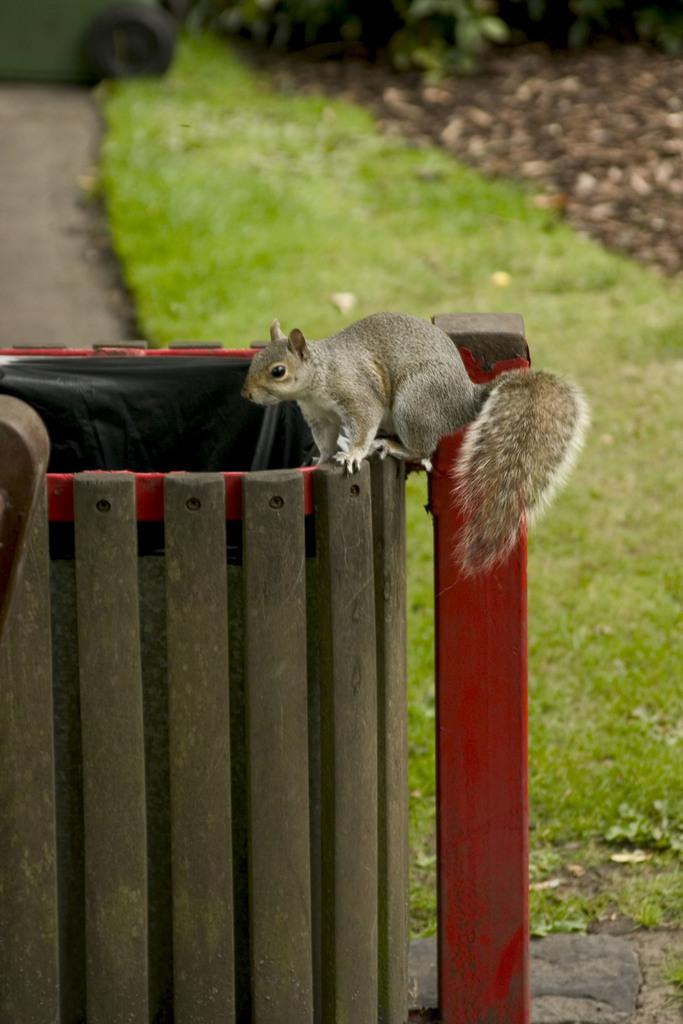What animal is present in the image? There is a squirrel in the image. Where is the squirrel located? The squirrel is on a bin. What type of vegetation can be seen in the background of the image? There is grass in the background of the image. What shape is the park in the image? There is no park present in the image, so it is not possible to determine its shape. 